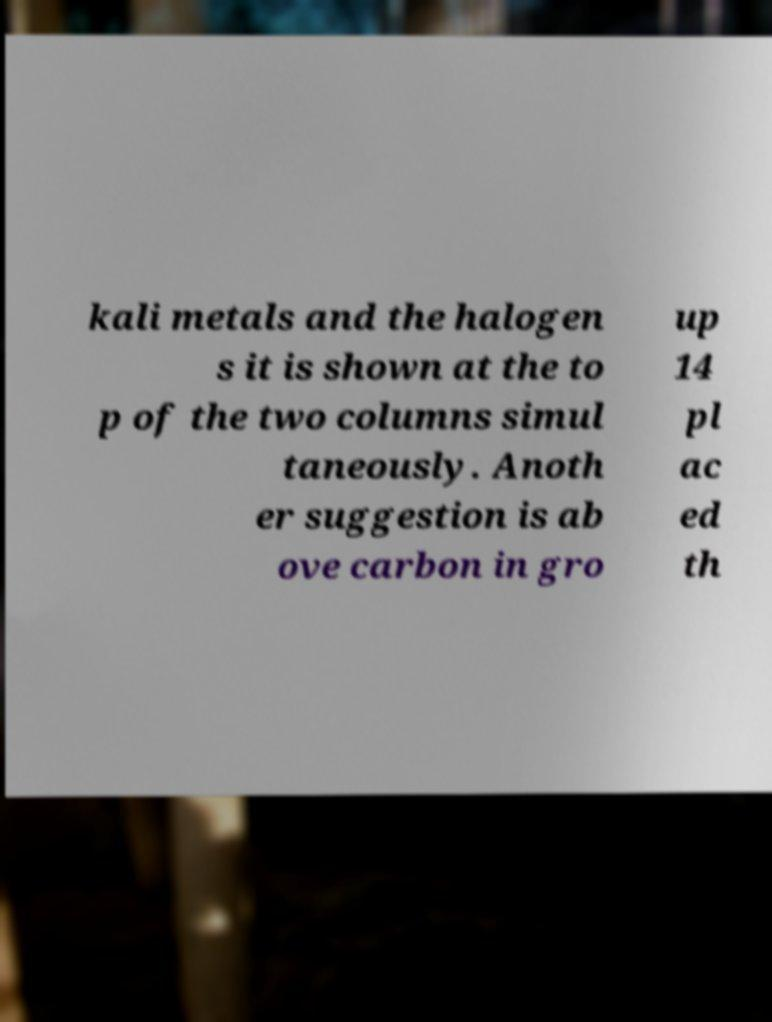Please identify and transcribe the text found in this image. kali metals and the halogen s it is shown at the to p of the two columns simul taneously. Anoth er suggestion is ab ove carbon in gro up 14 pl ac ed th 